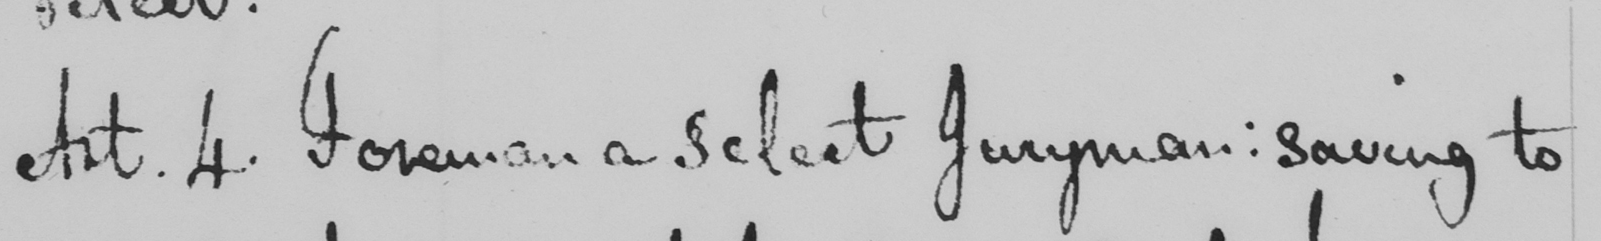Transcribe the text shown in this historical manuscript line. Art . 4 . Foreman a select Juryman :  saving to 